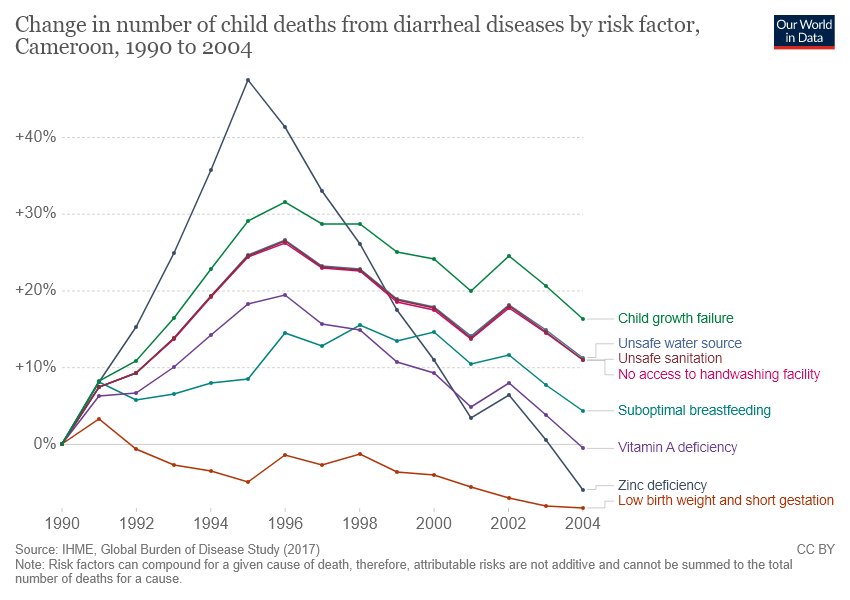Point out several critical features in this image. The change in the number of child deaths from diarrheal diseases due to zinc deficiency is greater than 30% in three years. The study found that child growth failure was responsible for more child deaths over the years compared to vitamin A deficiency. 